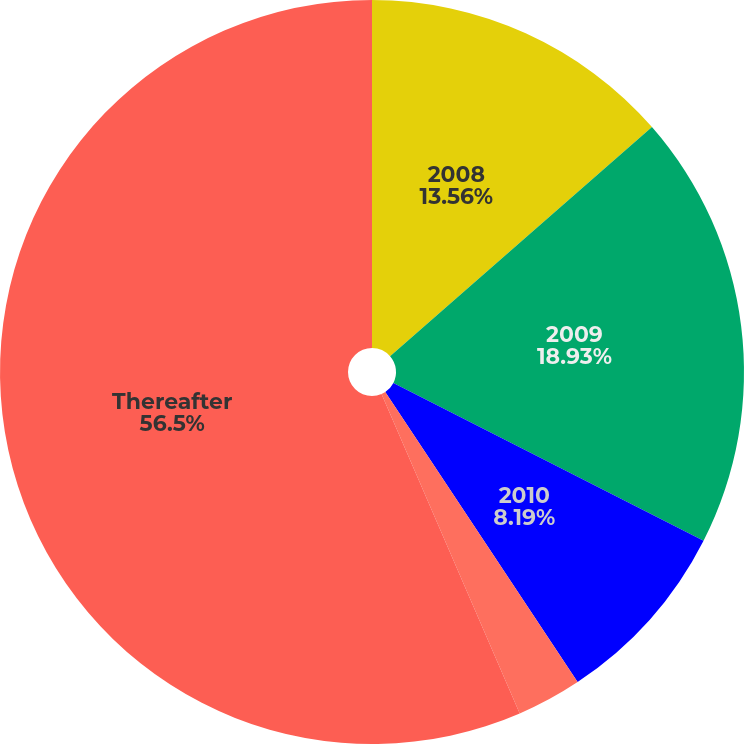Convert chart to OTSL. <chart><loc_0><loc_0><loc_500><loc_500><pie_chart><fcel>2008<fcel>2009<fcel>2010<fcel>2012<fcel>Thereafter<nl><fcel>13.56%<fcel>18.93%<fcel>8.19%<fcel>2.82%<fcel>56.5%<nl></chart> 